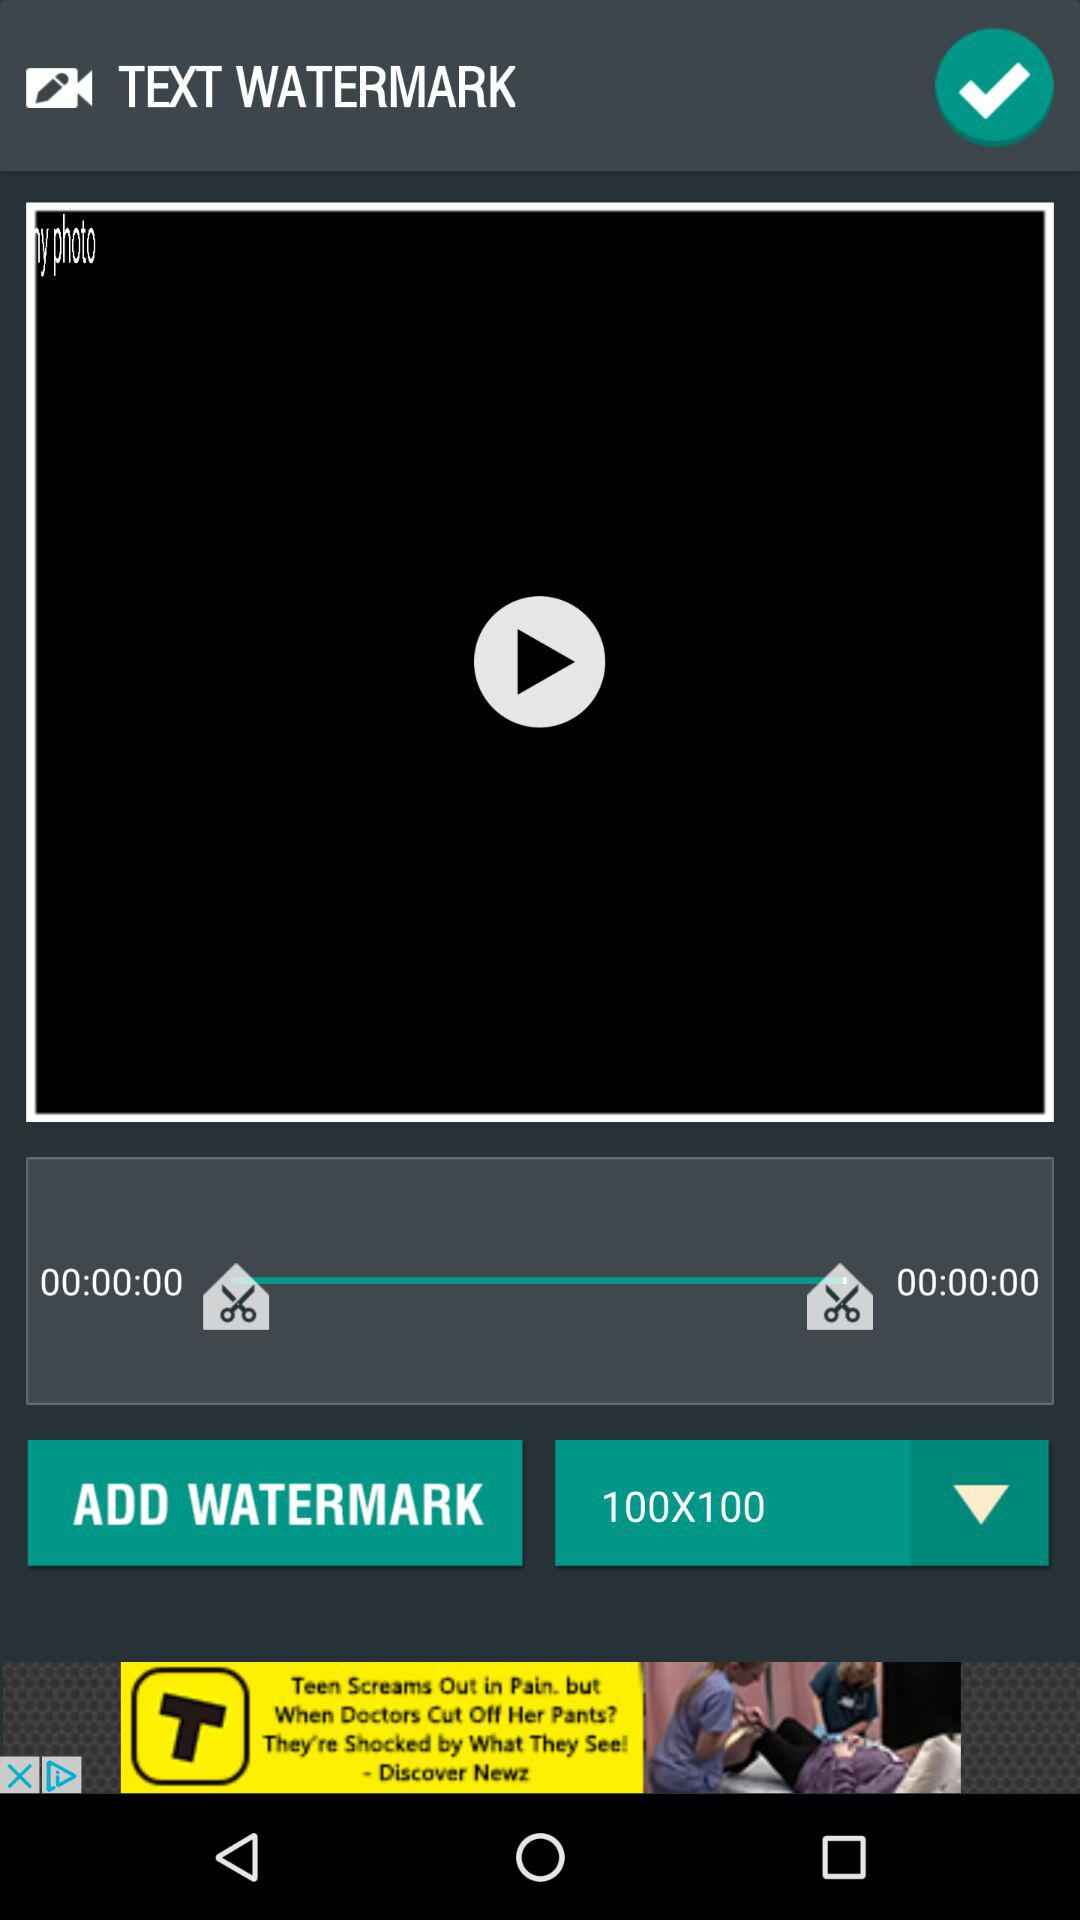What is the application name in the advertisement? The application name in the advertisement is "TopBuzz". 